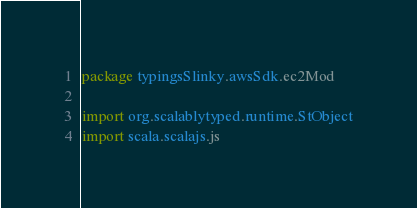<code> <loc_0><loc_0><loc_500><loc_500><_Scala_>package typingsSlinky.awsSdk.ec2Mod

import org.scalablytyped.runtime.StObject
import scala.scalajs.js</code> 